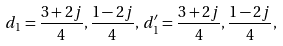<formula> <loc_0><loc_0><loc_500><loc_500>d _ { 1 } = \frac { 3 + 2 j } { 4 } , \frac { 1 - 2 j } { 4 } , \, d _ { 1 } ^ { \prime } = \frac { 3 + 2 j } { 4 } , \frac { 1 - 2 j } { 4 } ,</formula> 